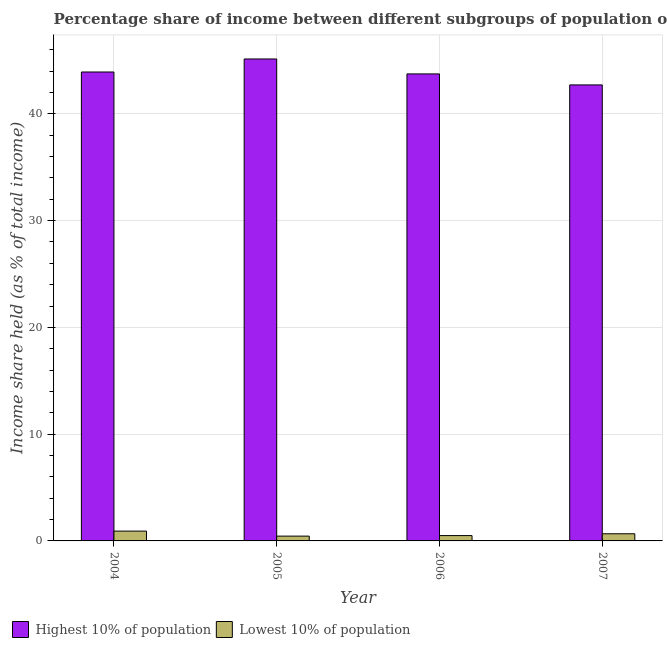Are the number of bars per tick equal to the number of legend labels?
Give a very brief answer. Yes. What is the label of the 4th group of bars from the left?
Your answer should be compact. 2007. What is the income share held by highest 10% of the population in 2006?
Offer a terse response. 43.74. Across all years, what is the minimum income share held by lowest 10% of the population?
Provide a short and direct response. 0.45. In which year was the income share held by lowest 10% of the population minimum?
Offer a terse response. 2005. What is the total income share held by highest 10% of the population in the graph?
Provide a short and direct response. 175.51. What is the difference between the income share held by lowest 10% of the population in 2005 and that in 2007?
Your answer should be compact. -0.22. What is the difference between the income share held by highest 10% of the population in 2005 and the income share held by lowest 10% of the population in 2007?
Give a very brief answer. 2.43. What is the average income share held by lowest 10% of the population per year?
Your answer should be very brief. 0.64. In the year 2004, what is the difference between the income share held by lowest 10% of the population and income share held by highest 10% of the population?
Keep it short and to the point. 0. In how many years, is the income share held by lowest 10% of the population greater than 18 %?
Offer a terse response. 0. What is the ratio of the income share held by lowest 10% of the population in 2004 to that in 2005?
Make the answer very short. 2.04. What is the difference between the highest and the second highest income share held by lowest 10% of the population?
Provide a short and direct response. 0.25. What is the difference between the highest and the lowest income share held by lowest 10% of the population?
Your answer should be compact. 0.47. What does the 1st bar from the left in 2006 represents?
Give a very brief answer. Highest 10% of population. What does the 1st bar from the right in 2007 represents?
Offer a very short reply. Lowest 10% of population. How many bars are there?
Your answer should be very brief. 8. Are the values on the major ticks of Y-axis written in scientific E-notation?
Provide a succinct answer. No. Where does the legend appear in the graph?
Make the answer very short. Bottom left. How many legend labels are there?
Give a very brief answer. 2. What is the title of the graph?
Offer a terse response. Percentage share of income between different subgroups of population of Bolivia. Does "Primary" appear as one of the legend labels in the graph?
Provide a succinct answer. No. What is the label or title of the Y-axis?
Provide a short and direct response. Income share held (as % of total income). What is the Income share held (as % of total income) of Highest 10% of population in 2004?
Your response must be concise. 43.92. What is the Income share held (as % of total income) of Highest 10% of population in 2005?
Your answer should be compact. 45.14. What is the Income share held (as % of total income) of Lowest 10% of population in 2005?
Your answer should be compact. 0.45. What is the Income share held (as % of total income) in Highest 10% of population in 2006?
Your answer should be compact. 43.74. What is the Income share held (as % of total income) of Lowest 10% of population in 2006?
Your response must be concise. 0.5. What is the Income share held (as % of total income) of Highest 10% of population in 2007?
Make the answer very short. 42.71. What is the Income share held (as % of total income) in Lowest 10% of population in 2007?
Your answer should be very brief. 0.67. Across all years, what is the maximum Income share held (as % of total income) in Highest 10% of population?
Offer a very short reply. 45.14. Across all years, what is the maximum Income share held (as % of total income) in Lowest 10% of population?
Provide a short and direct response. 0.92. Across all years, what is the minimum Income share held (as % of total income) in Highest 10% of population?
Provide a succinct answer. 42.71. Across all years, what is the minimum Income share held (as % of total income) in Lowest 10% of population?
Your answer should be compact. 0.45. What is the total Income share held (as % of total income) of Highest 10% of population in the graph?
Give a very brief answer. 175.51. What is the total Income share held (as % of total income) in Lowest 10% of population in the graph?
Offer a terse response. 2.54. What is the difference between the Income share held (as % of total income) of Highest 10% of population in 2004 and that in 2005?
Make the answer very short. -1.22. What is the difference between the Income share held (as % of total income) of Lowest 10% of population in 2004 and that in 2005?
Keep it short and to the point. 0.47. What is the difference between the Income share held (as % of total income) of Highest 10% of population in 2004 and that in 2006?
Give a very brief answer. 0.18. What is the difference between the Income share held (as % of total income) in Lowest 10% of population in 2004 and that in 2006?
Ensure brevity in your answer.  0.42. What is the difference between the Income share held (as % of total income) in Highest 10% of population in 2004 and that in 2007?
Give a very brief answer. 1.21. What is the difference between the Income share held (as % of total income) of Lowest 10% of population in 2004 and that in 2007?
Provide a succinct answer. 0.25. What is the difference between the Income share held (as % of total income) in Highest 10% of population in 2005 and that in 2007?
Your answer should be very brief. 2.43. What is the difference between the Income share held (as % of total income) in Lowest 10% of population in 2005 and that in 2007?
Offer a very short reply. -0.22. What is the difference between the Income share held (as % of total income) in Lowest 10% of population in 2006 and that in 2007?
Provide a short and direct response. -0.17. What is the difference between the Income share held (as % of total income) of Highest 10% of population in 2004 and the Income share held (as % of total income) of Lowest 10% of population in 2005?
Your answer should be compact. 43.47. What is the difference between the Income share held (as % of total income) of Highest 10% of population in 2004 and the Income share held (as % of total income) of Lowest 10% of population in 2006?
Provide a short and direct response. 43.42. What is the difference between the Income share held (as % of total income) of Highest 10% of population in 2004 and the Income share held (as % of total income) of Lowest 10% of population in 2007?
Provide a succinct answer. 43.25. What is the difference between the Income share held (as % of total income) of Highest 10% of population in 2005 and the Income share held (as % of total income) of Lowest 10% of population in 2006?
Provide a succinct answer. 44.64. What is the difference between the Income share held (as % of total income) in Highest 10% of population in 2005 and the Income share held (as % of total income) in Lowest 10% of population in 2007?
Your answer should be compact. 44.47. What is the difference between the Income share held (as % of total income) of Highest 10% of population in 2006 and the Income share held (as % of total income) of Lowest 10% of population in 2007?
Provide a short and direct response. 43.07. What is the average Income share held (as % of total income) in Highest 10% of population per year?
Your answer should be very brief. 43.88. What is the average Income share held (as % of total income) in Lowest 10% of population per year?
Keep it short and to the point. 0.64. In the year 2004, what is the difference between the Income share held (as % of total income) in Highest 10% of population and Income share held (as % of total income) in Lowest 10% of population?
Give a very brief answer. 43. In the year 2005, what is the difference between the Income share held (as % of total income) in Highest 10% of population and Income share held (as % of total income) in Lowest 10% of population?
Offer a terse response. 44.69. In the year 2006, what is the difference between the Income share held (as % of total income) of Highest 10% of population and Income share held (as % of total income) of Lowest 10% of population?
Offer a terse response. 43.24. In the year 2007, what is the difference between the Income share held (as % of total income) of Highest 10% of population and Income share held (as % of total income) of Lowest 10% of population?
Provide a succinct answer. 42.04. What is the ratio of the Income share held (as % of total income) in Lowest 10% of population in 2004 to that in 2005?
Provide a short and direct response. 2.04. What is the ratio of the Income share held (as % of total income) of Lowest 10% of population in 2004 to that in 2006?
Provide a succinct answer. 1.84. What is the ratio of the Income share held (as % of total income) of Highest 10% of population in 2004 to that in 2007?
Your response must be concise. 1.03. What is the ratio of the Income share held (as % of total income) in Lowest 10% of population in 2004 to that in 2007?
Make the answer very short. 1.37. What is the ratio of the Income share held (as % of total income) in Highest 10% of population in 2005 to that in 2006?
Make the answer very short. 1.03. What is the ratio of the Income share held (as % of total income) in Highest 10% of population in 2005 to that in 2007?
Your answer should be compact. 1.06. What is the ratio of the Income share held (as % of total income) in Lowest 10% of population in 2005 to that in 2007?
Ensure brevity in your answer.  0.67. What is the ratio of the Income share held (as % of total income) in Highest 10% of population in 2006 to that in 2007?
Make the answer very short. 1.02. What is the ratio of the Income share held (as % of total income) in Lowest 10% of population in 2006 to that in 2007?
Give a very brief answer. 0.75. What is the difference between the highest and the second highest Income share held (as % of total income) of Highest 10% of population?
Provide a short and direct response. 1.22. What is the difference between the highest and the lowest Income share held (as % of total income) in Highest 10% of population?
Ensure brevity in your answer.  2.43. What is the difference between the highest and the lowest Income share held (as % of total income) of Lowest 10% of population?
Offer a very short reply. 0.47. 